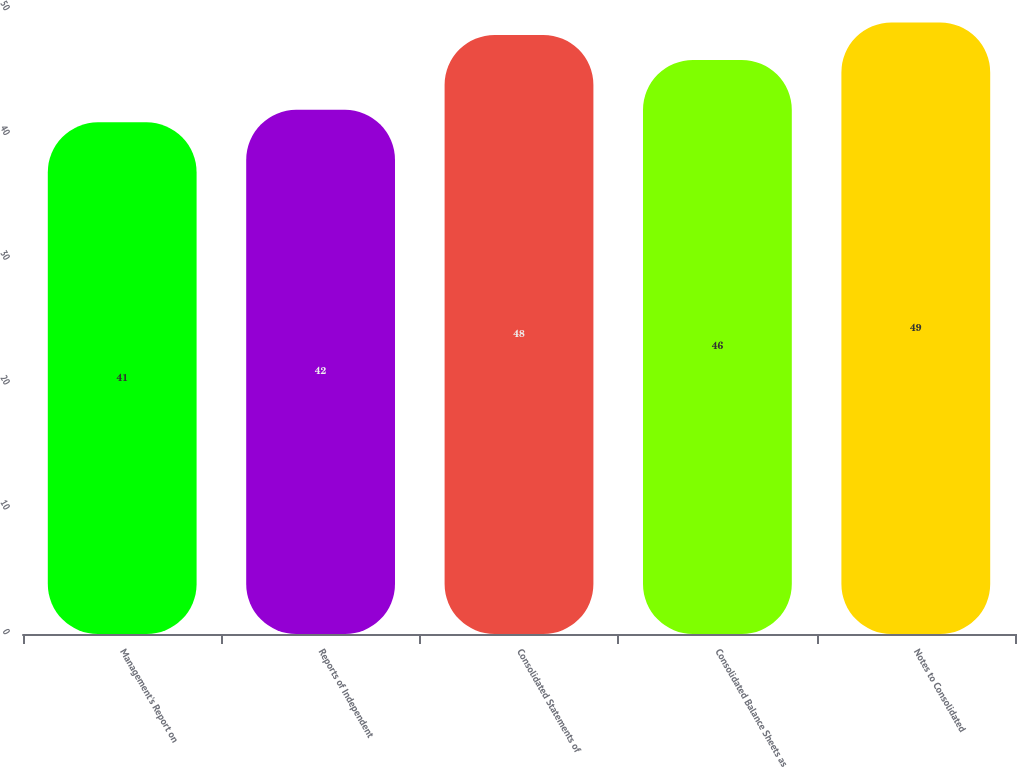Convert chart to OTSL. <chart><loc_0><loc_0><loc_500><loc_500><bar_chart><fcel>Management's Report on<fcel>Reports of Independent<fcel>Consolidated Statements of<fcel>Consolidated Balance Sheets as<fcel>Notes to Consolidated<nl><fcel>41<fcel>42<fcel>48<fcel>46<fcel>49<nl></chart> 